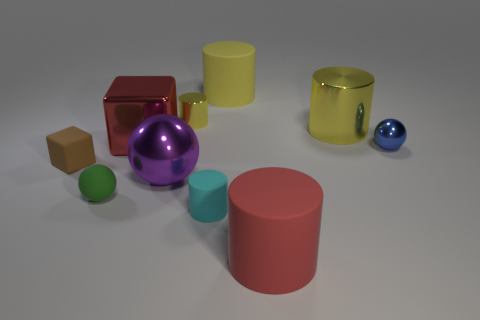Is the material of the small yellow object to the left of the blue metal object the same as the small cyan cylinder?
Provide a short and direct response. No. There is a large metal object in front of the tiny ball behind the large purple metallic thing; how many big red things are in front of it?
Your answer should be compact. 1. The yellow rubber cylinder is what size?
Provide a short and direct response. Large. Does the tiny shiny cylinder have the same color as the big metal cylinder?
Give a very brief answer. Yes. How big is the rubber cylinder behind the red metallic cube?
Offer a very short reply. Large. Do the matte thing in front of the cyan thing and the shiny object to the left of the purple thing have the same color?
Provide a succinct answer. Yes. What number of other objects are the same shape as the tiny blue object?
Offer a very short reply. 2. Are there the same number of tiny yellow cylinders that are in front of the purple shiny thing and brown rubber things to the right of the tiny block?
Ensure brevity in your answer.  Yes. Do the small thing that is behind the red shiny cube and the large red thing in front of the brown matte block have the same material?
Provide a short and direct response. No. How many other things are there of the same size as the green ball?
Keep it short and to the point. 4. 